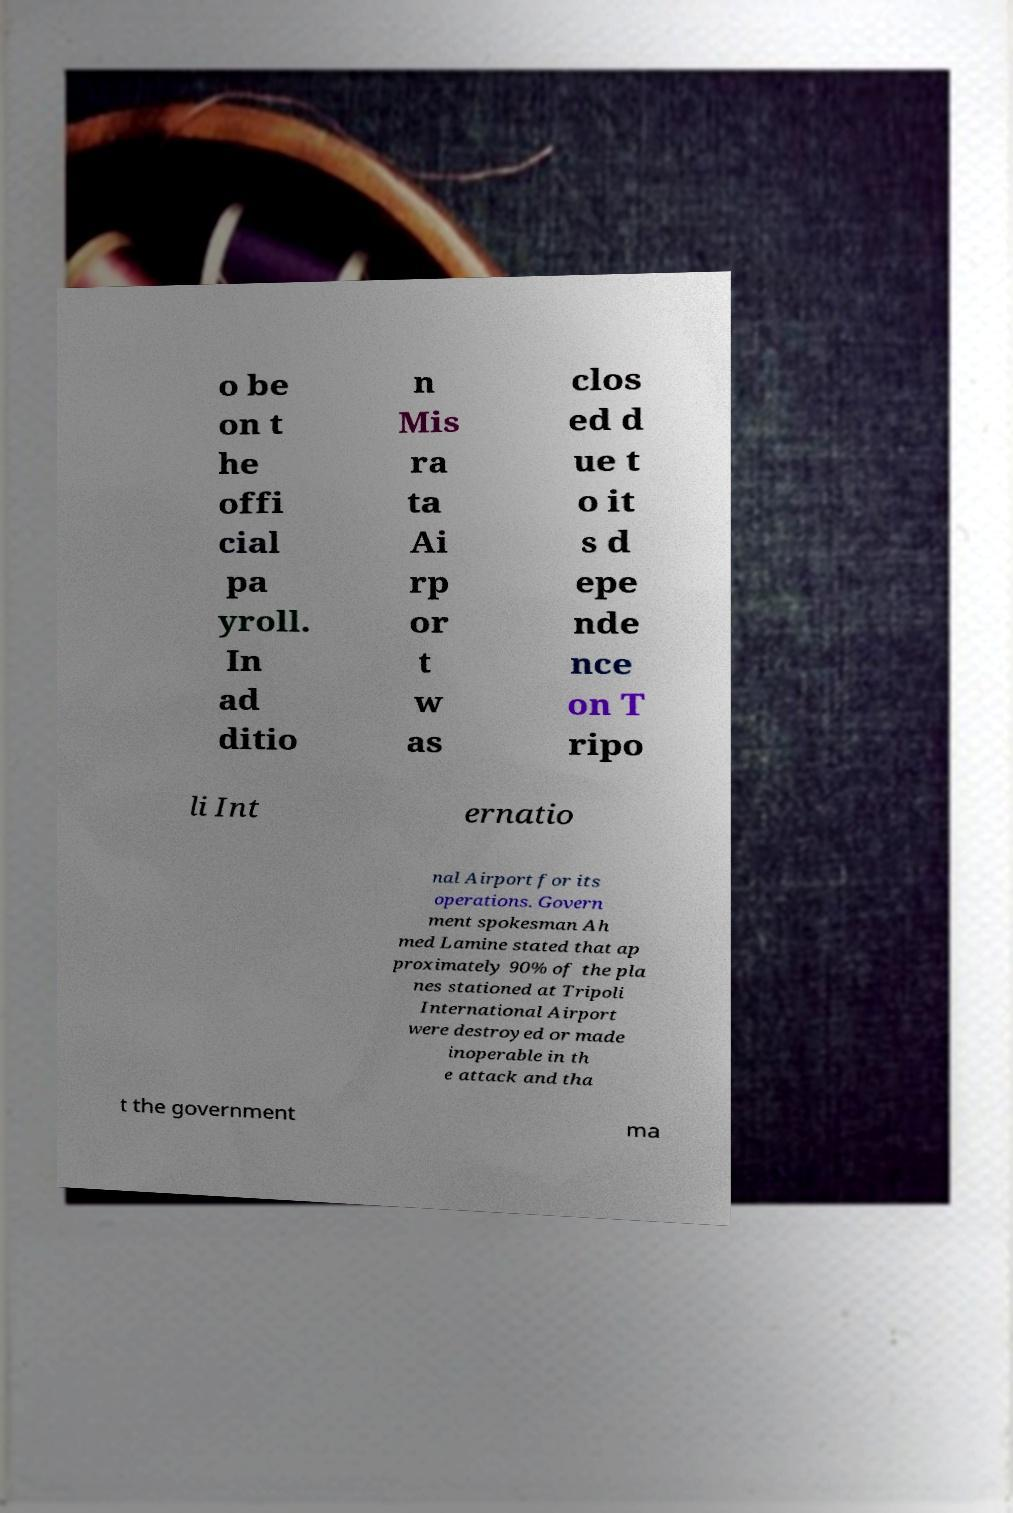Please read and relay the text visible in this image. What does it say? o be on t he offi cial pa yroll. In ad ditio n Mis ra ta Ai rp or t w as clos ed d ue t o it s d epe nde nce on T ripo li Int ernatio nal Airport for its operations. Govern ment spokesman Ah med Lamine stated that ap proximately 90% of the pla nes stationed at Tripoli International Airport were destroyed or made inoperable in th e attack and tha t the government ma 